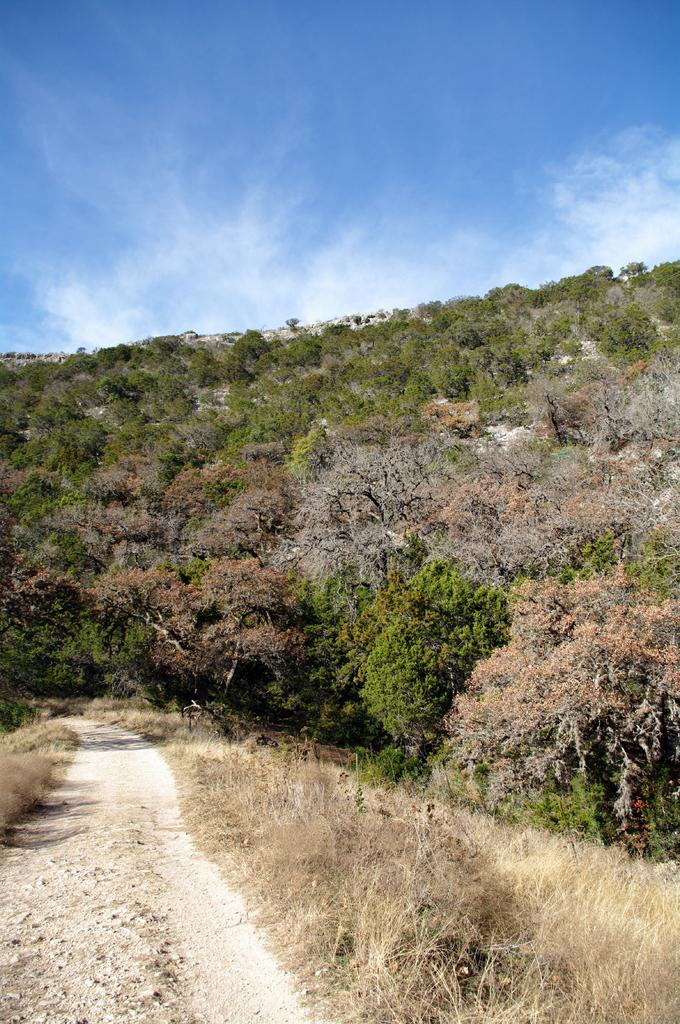What type of vegetation can be seen in the image? There are plants, trees, and grass in the image. What is the ground covered with in the image? The ground is covered with grass and stones in the image. What is visible in the background of the image? The sky is visible in the image. What type of quiver can be seen in the image? There is no quiver present in the image. Can you tell me how many animals are in the zoo in the image? There is no zoo present in the image. 